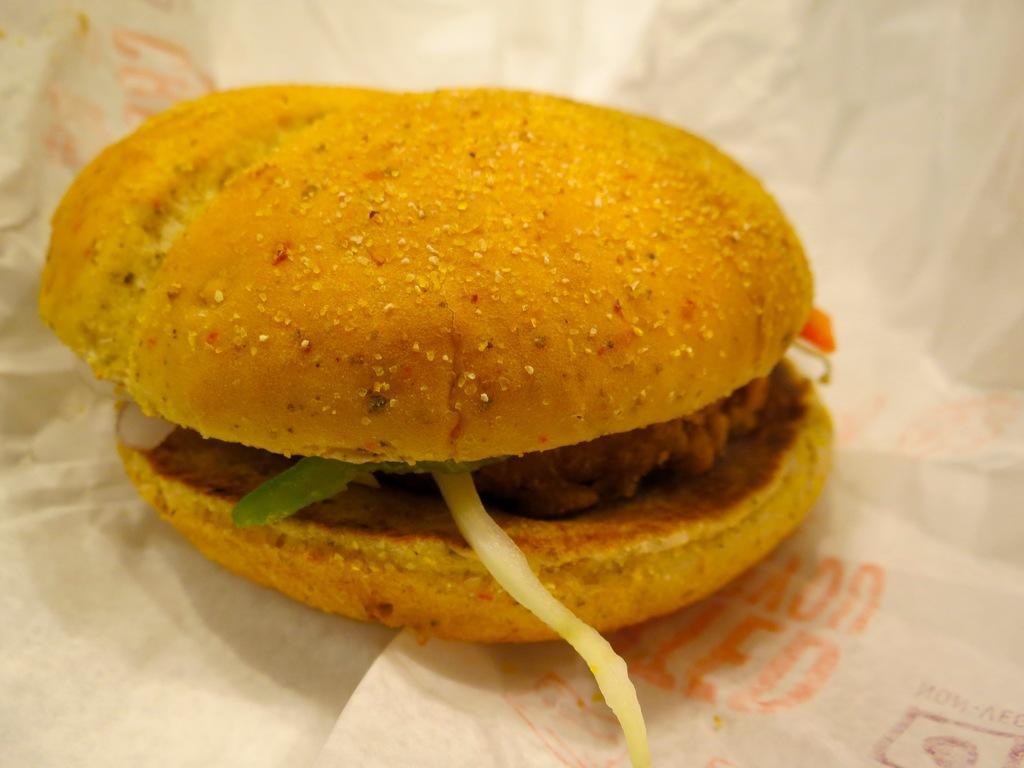Describe this image in one or two sentences. In this image there is one burger in middle of this image is kept on white color paper. 